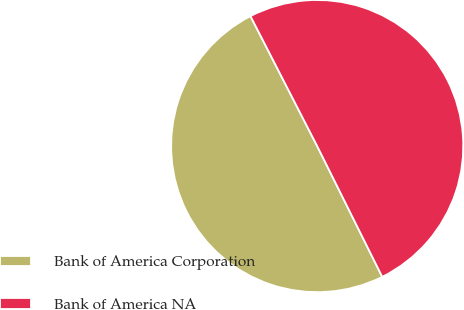Convert chart. <chart><loc_0><loc_0><loc_500><loc_500><pie_chart><fcel>Bank of America Corporation<fcel>Bank of America NA<nl><fcel>49.8%<fcel>50.2%<nl></chart> 